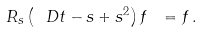<formula> <loc_0><loc_0><loc_500><loc_500>R _ { s } \left ( \ D t - s + s ^ { 2 } \right ) f \ = f \, .</formula> 